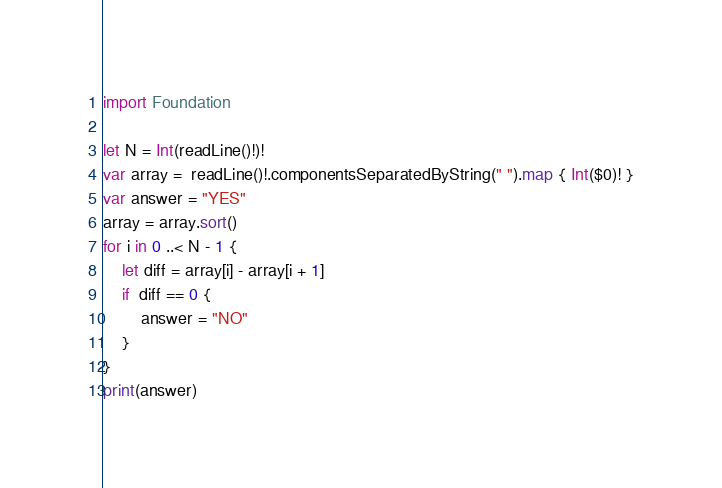Convert code to text. <code><loc_0><loc_0><loc_500><loc_500><_Swift_>import Foundation
 
let N = Int(readLine()!)!
var array =  readLine()!.componentsSeparatedByString(" ").map { Int($0)! }
var answer = "YES"
array = array.sort()
for i in 0 ..< N - 1 {
  	let diff = array[i] - array[i + 1]
    if  diff == 0 {
        answer = "NO"
    }
}
print(answer)</code> 